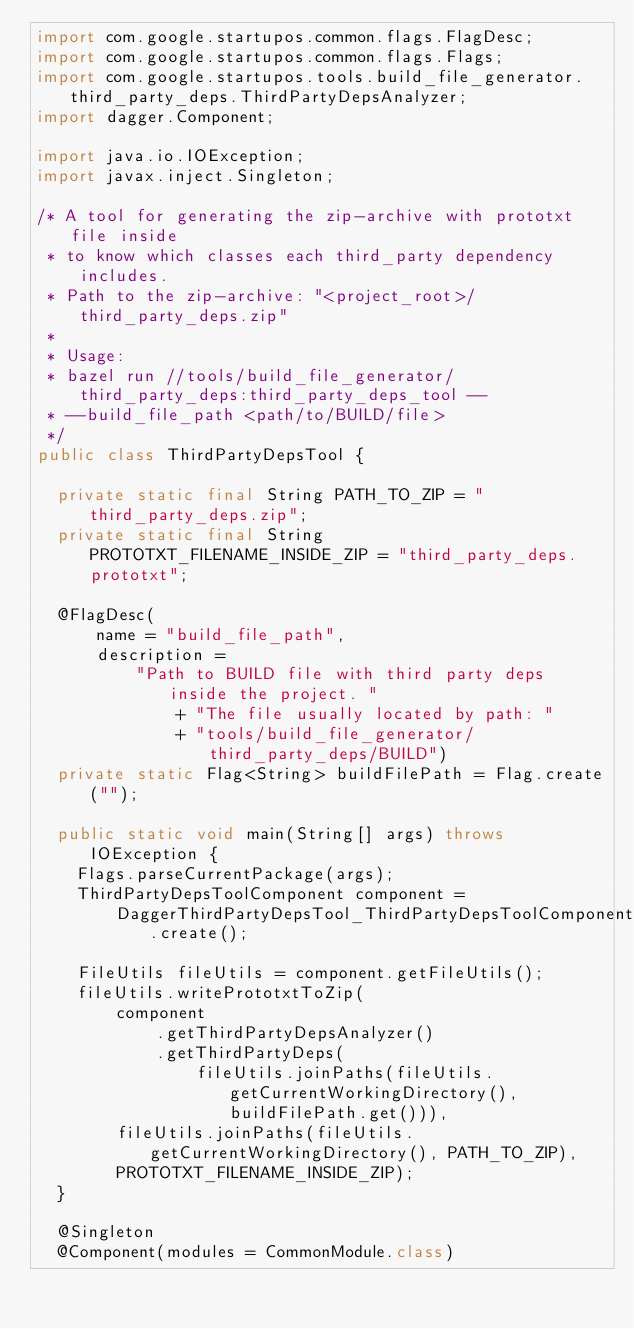Convert code to text. <code><loc_0><loc_0><loc_500><loc_500><_Java_>import com.google.startupos.common.flags.FlagDesc;
import com.google.startupos.common.flags.Flags;
import com.google.startupos.tools.build_file_generator.third_party_deps.ThirdPartyDepsAnalyzer;
import dagger.Component;

import java.io.IOException;
import javax.inject.Singleton;

/* A tool for generating the zip-archive with prototxt file inside
 * to know which classes each third_party dependency includes.
 * Path to the zip-archive: "<project_root>/third_party_deps.zip"
 *
 * Usage:
 * bazel run //tools/build_file_generator/third_party_deps:third_party_deps_tool --
 * --build_file_path <path/to/BUILD/file>
 */
public class ThirdPartyDepsTool {

  private static final String PATH_TO_ZIP = "third_party_deps.zip";
  private static final String PROTOTXT_FILENAME_INSIDE_ZIP = "third_party_deps.prototxt";

  @FlagDesc(
      name = "build_file_path",
      description =
          "Path to BUILD file with third party deps inside the project. "
              + "The file usually located by path: "
              + "tools/build_file_generator/third_party_deps/BUILD")
  private static Flag<String> buildFilePath = Flag.create("");

  public static void main(String[] args) throws IOException {
    Flags.parseCurrentPackage(args);
    ThirdPartyDepsToolComponent component =
        DaggerThirdPartyDepsTool_ThirdPartyDepsToolComponent.create();

    FileUtils fileUtils = component.getFileUtils();
    fileUtils.writePrototxtToZip(
        component
            .getThirdPartyDepsAnalyzer()
            .getThirdPartyDeps(
                fileUtils.joinPaths(fileUtils.getCurrentWorkingDirectory(), buildFilePath.get())),
        fileUtils.joinPaths(fileUtils.getCurrentWorkingDirectory(), PATH_TO_ZIP),
        PROTOTXT_FILENAME_INSIDE_ZIP);
  }

  @Singleton
  @Component(modules = CommonModule.class)</code> 